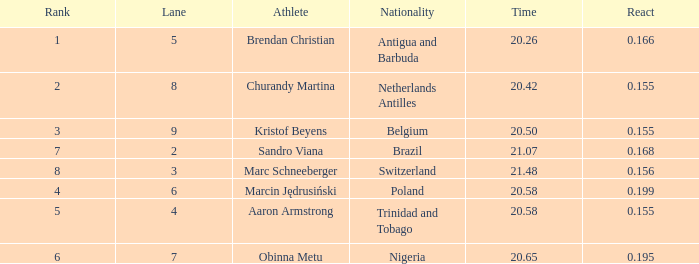Which Lane has a Time larger than 20.5, and a Nationality of trinidad and tobago? 4.0. 